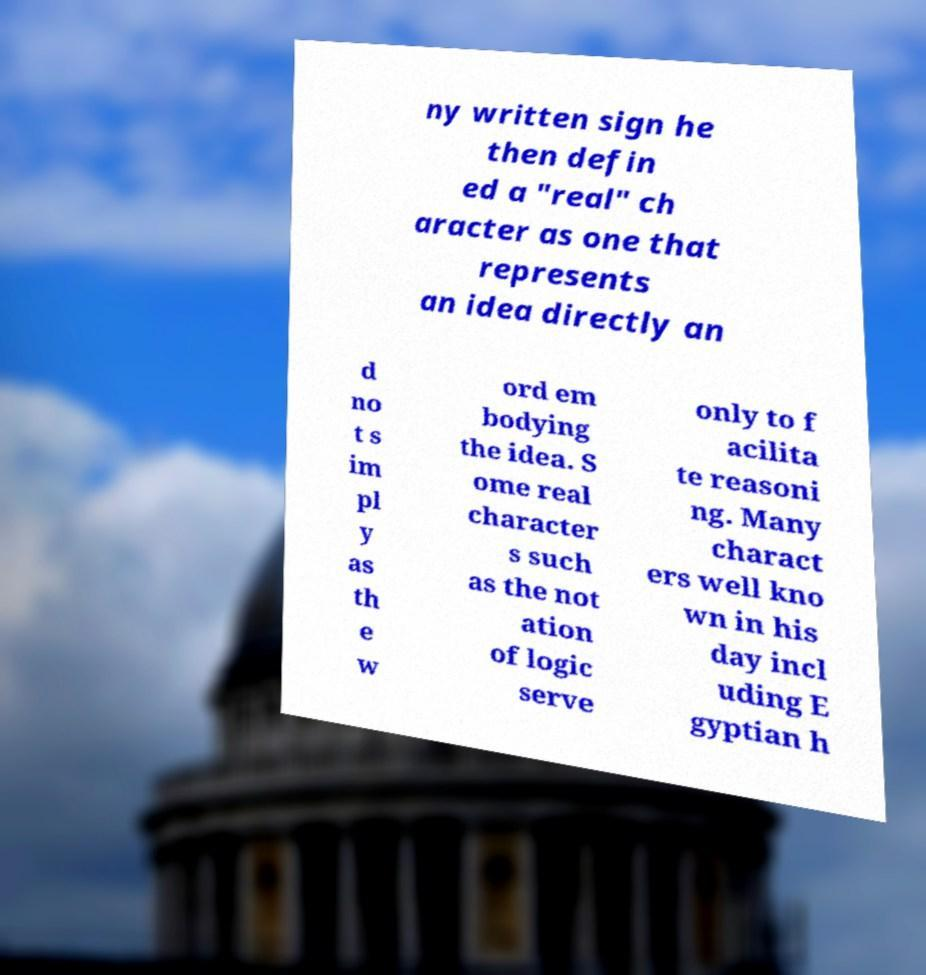Can you read and provide the text displayed in the image?This photo seems to have some interesting text. Can you extract and type it out for me? ny written sign he then defin ed a "real" ch aracter as one that represents an idea directly an d no t s im pl y as th e w ord em bodying the idea. S ome real character s such as the not ation of logic serve only to f acilita te reasoni ng. Many charact ers well kno wn in his day incl uding E gyptian h 